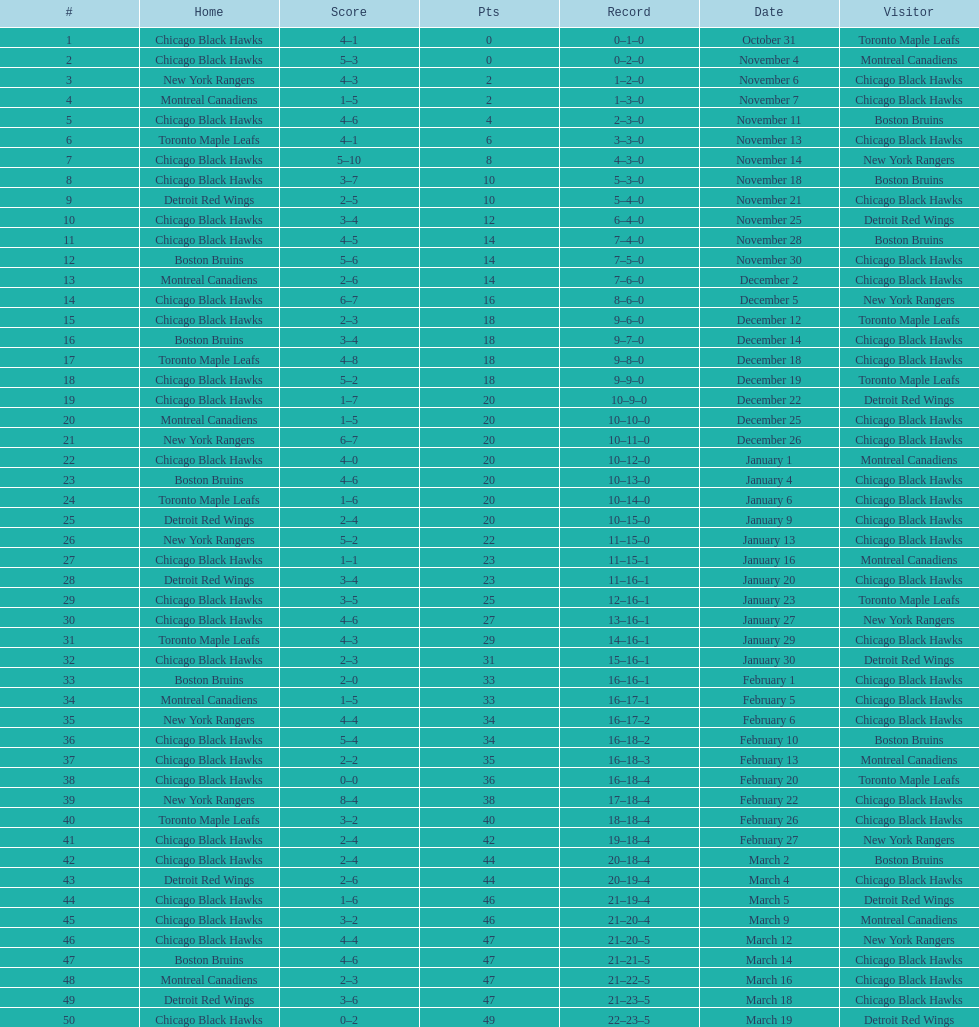How many games total were played? 50. 